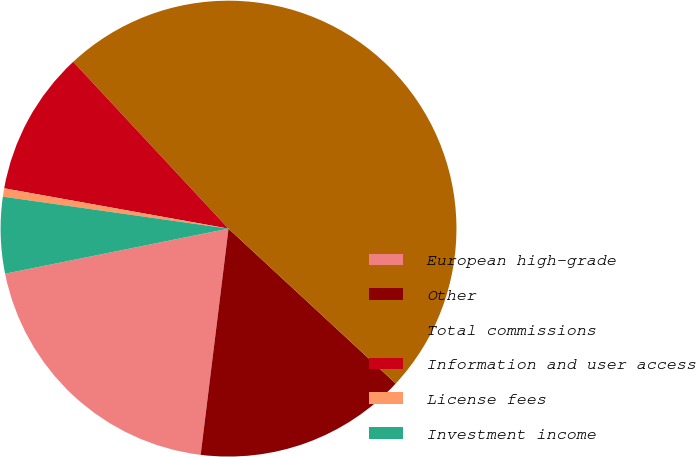Convert chart. <chart><loc_0><loc_0><loc_500><loc_500><pie_chart><fcel>European high-grade<fcel>Other<fcel>Total commissions<fcel>Information and user access<fcel>License fees<fcel>Investment income<nl><fcel>19.88%<fcel>15.06%<fcel>48.82%<fcel>10.24%<fcel>0.59%<fcel>5.41%<nl></chart> 